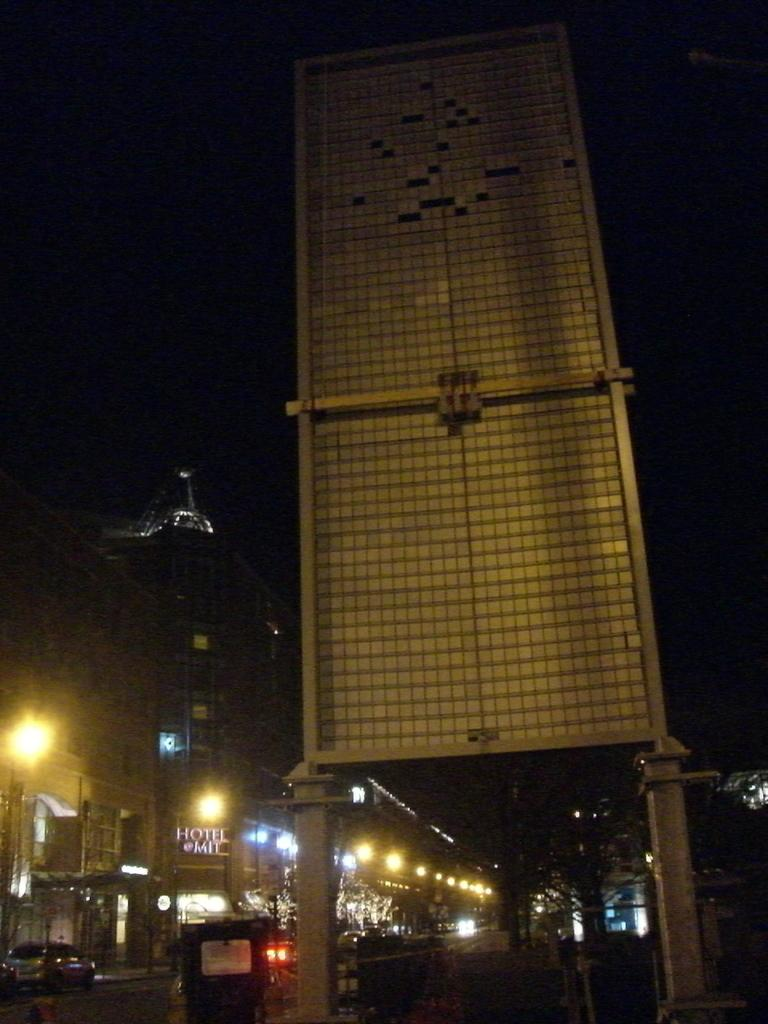What can be seen on the road in the image? There are vehicles on the road in the image. What else is visible in the image besides the vehicles? There are lights, buildings, trees, and some objects visible in the image. Can you describe the background of the image? The background of the image appears dark. What type of agreement is being signed in the image? There is no agreement or signing activity present in the image. How many cakes are visible on the table in the image? There are no cakes or tables present in the image. 